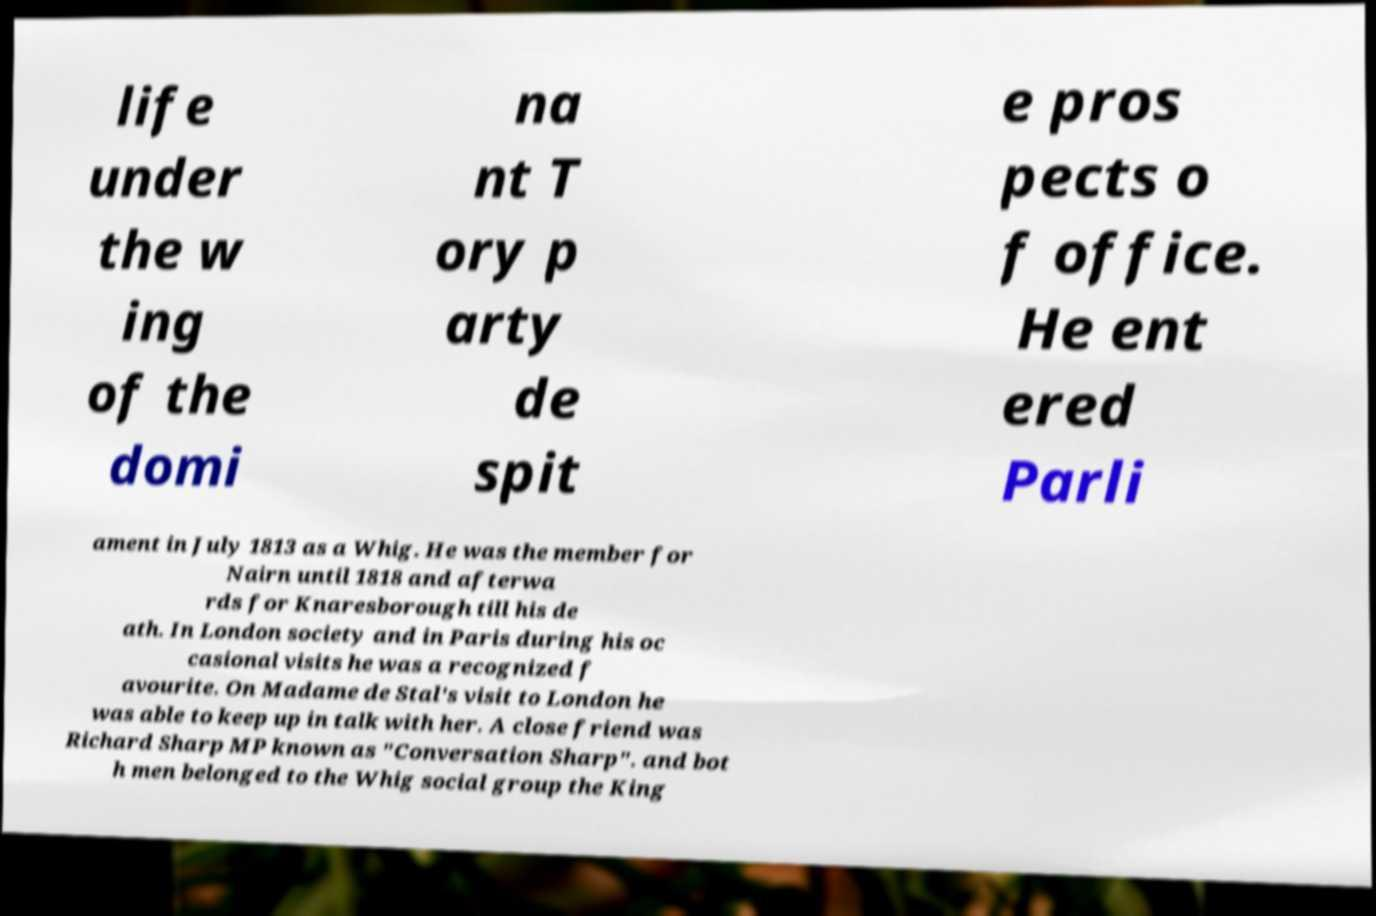Could you extract and type out the text from this image? life under the w ing of the domi na nt T ory p arty de spit e pros pects o f office. He ent ered Parli ament in July 1813 as a Whig. He was the member for Nairn until 1818 and afterwa rds for Knaresborough till his de ath. In London society and in Paris during his oc casional visits he was a recognized f avourite. On Madame de Stal's visit to London he was able to keep up in talk with her. A close friend was Richard Sharp MP known as "Conversation Sharp". and bot h men belonged to the Whig social group the King 